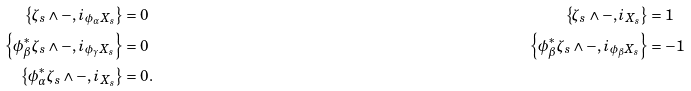Convert formula to latex. <formula><loc_0><loc_0><loc_500><loc_500>\left \{ \zeta _ { s } \wedge - , i _ { \phi _ { \alpha } X _ { s } } \right \} & = 0 & \left \{ \zeta _ { s } \wedge - , i _ { X _ { s } } \right \} & = 1 \\ \left \{ \phi _ { \beta } ^ { * } \zeta _ { s } \wedge - , i _ { \phi _ { \gamma } X _ { s } } \right \} & = 0 & \left \{ \phi _ { \beta } ^ { * } \zeta _ { s } \wedge - , i _ { \phi _ { \beta } X _ { s } } \right \} & = - 1 \\ \left \{ \phi _ { \alpha } ^ { * } \zeta _ { s } \wedge - , i _ { X _ { s } } \right \} & = 0 .</formula> 